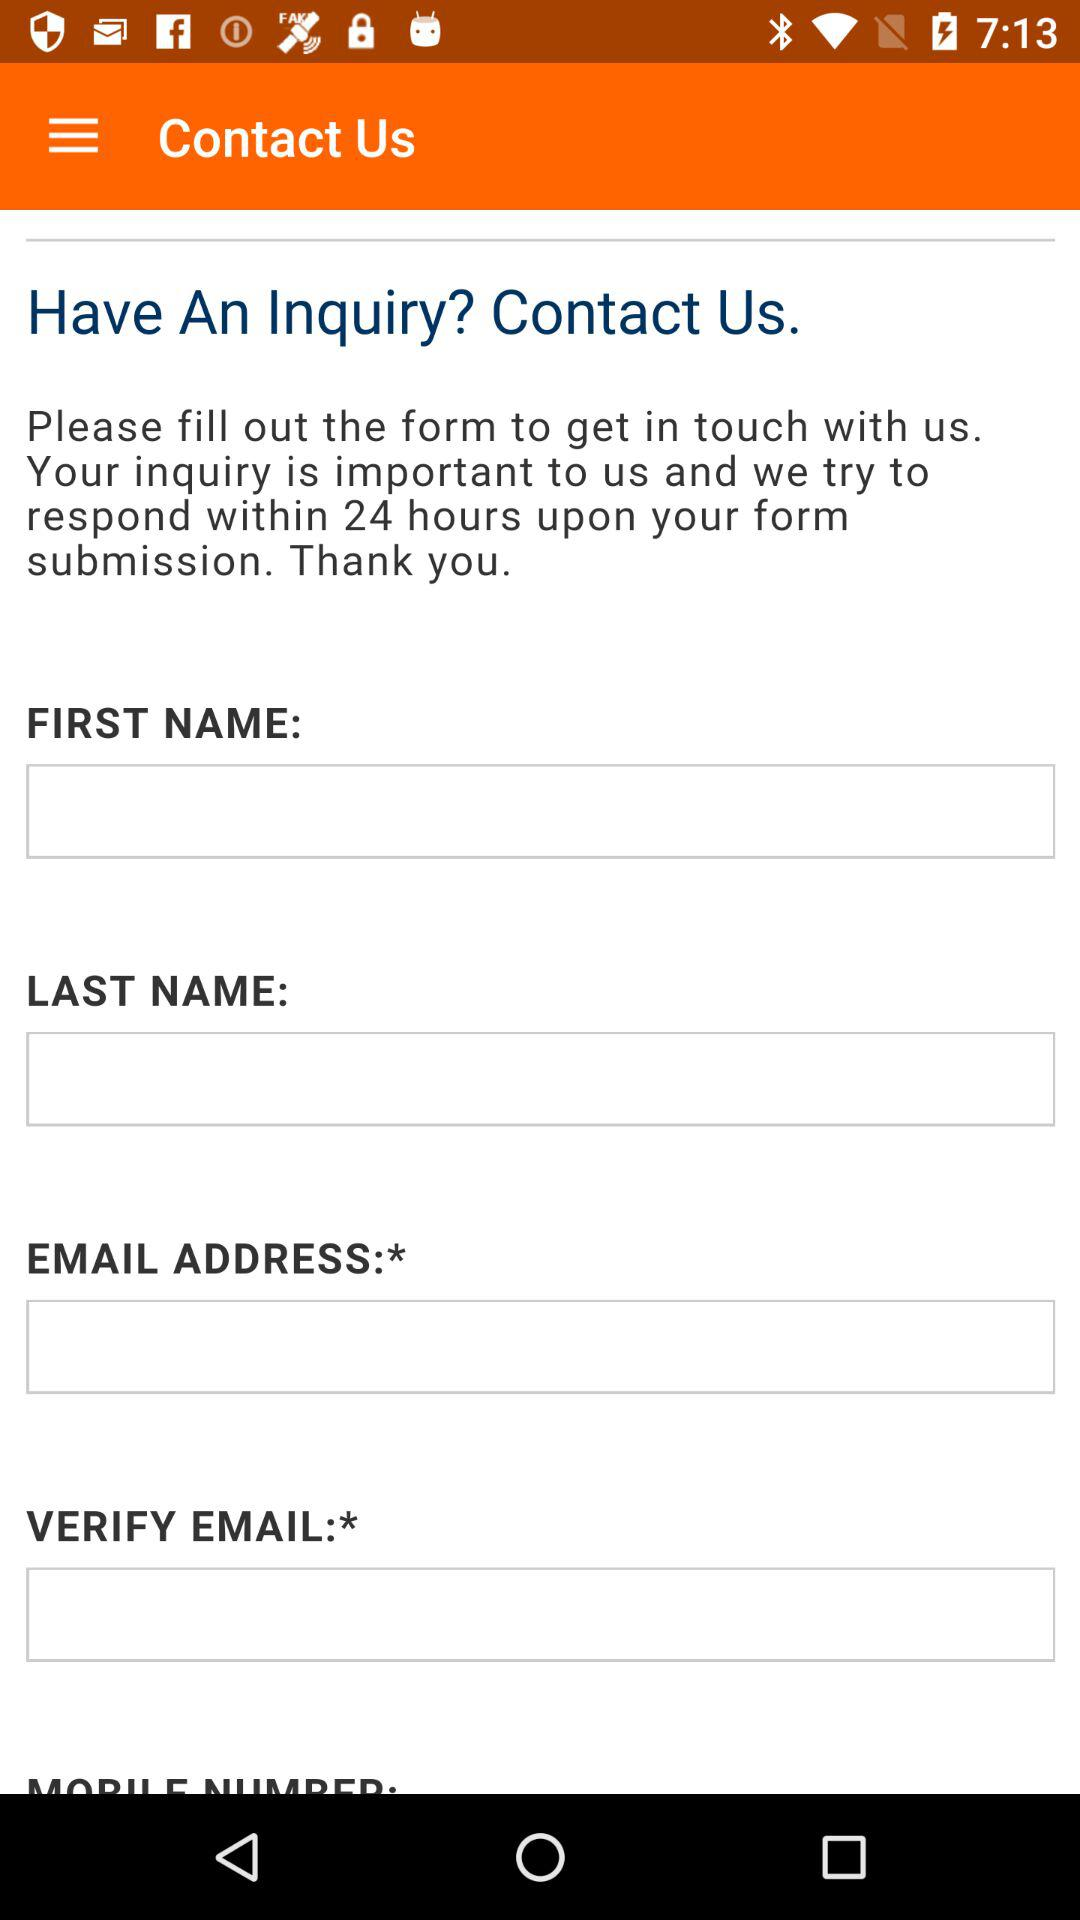Within how many hours do we get the response to our query? You get the response to your query within 24 hours. 